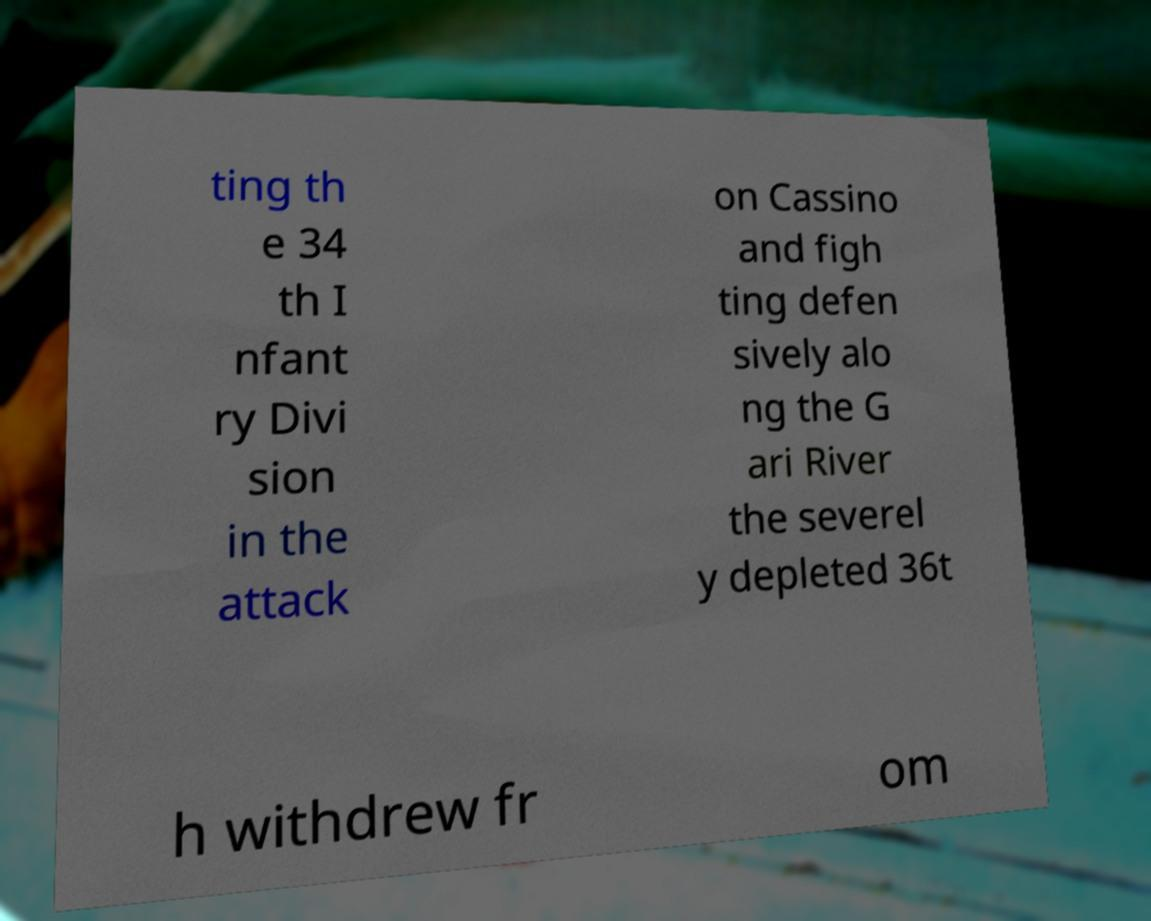I need the written content from this picture converted into text. Can you do that? ting th e 34 th I nfant ry Divi sion in the attack on Cassino and figh ting defen sively alo ng the G ari River the severel y depleted 36t h withdrew fr om 